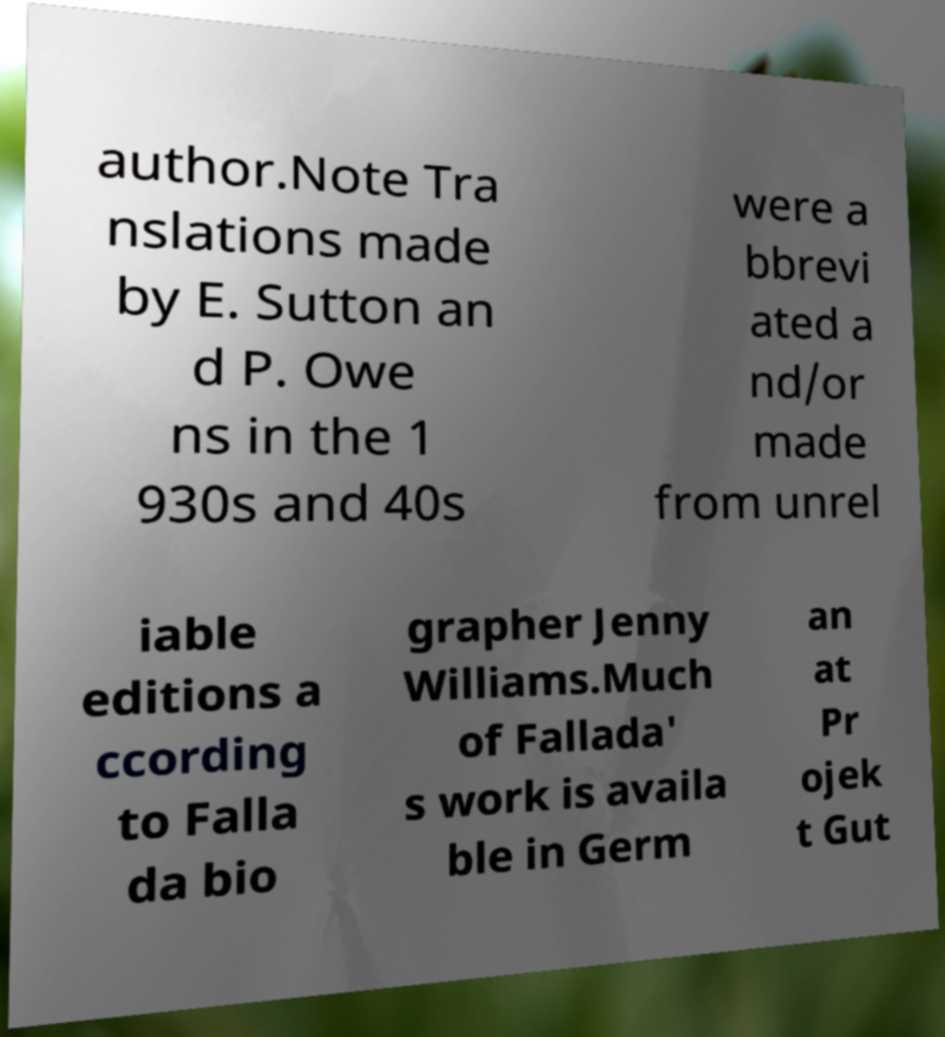Please read and relay the text visible in this image. What does it say? author.Note Tra nslations made by E. Sutton an d P. Owe ns in the 1 930s and 40s were a bbrevi ated a nd/or made from unrel iable editions a ccording to Falla da bio grapher Jenny Williams.Much of Fallada' s work is availa ble in Germ an at Pr ojek t Gut 